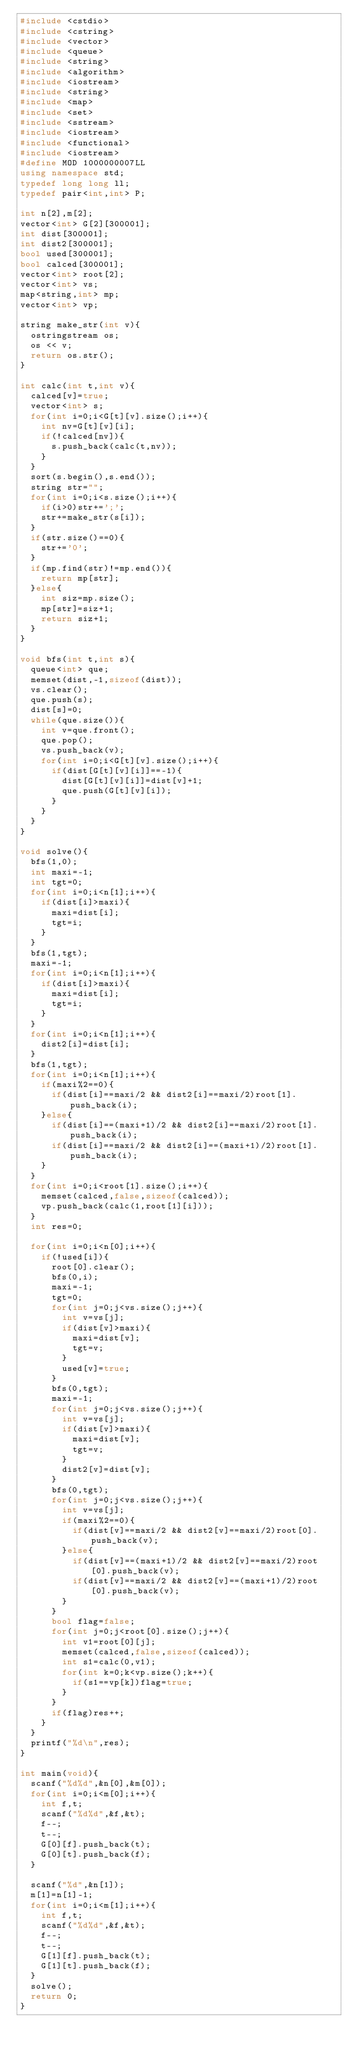<code> <loc_0><loc_0><loc_500><loc_500><_C++_>#include <cstdio>
#include <cstring>
#include <vector>
#include <queue>
#include <string>
#include <algorithm>
#include <iostream>
#include <string>
#include <map>
#include <set>
#include <sstream>
#include <iostream>
#include <functional>
#include <iostream>
#define MOD 1000000007LL
using namespace std;
typedef long long ll;
typedef pair<int,int> P;

int n[2],m[2];
vector<int> G[2][300001];
int dist[300001];
int dist2[300001];
bool used[300001];
bool calced[300001];
vector<int> root[2];
vector<int> vs;
map<string,int> mp;
vector<int> vp;

string make_str(int v){
	ostringstream os;
	os << v;
	return os.str();
}

int calc(int t,int v){
	calced[v]=true;
	vector<int> s;
	for(int i=0;i<G[t][v].size();i++){
		int nv=G[t][v][i];
		if(!calced[nv]){
			s.push_back(calc(t,nv));
		}
	}
	sort(s.begin(),s.end());
	string str="";
	for(int i=0;i<s.size();i++){
		if(i>0)str+=';';
		str+=make_str(s[i]);
	}
	if(str.size()==0){
		str+='0';
	}
	if(mp.find(str)!=mp.end()){
		return mp[str];
	}else{
		int siz=mp.size();
		mp[str]=siz+1;
		return siz+1;
	}
}

void bfs(int t,int s){
	queue<int> que;
	memset(dist,-1,sizeof(dist));
	vs.clear();
	que.push(s);
	dist[s]=0;
	while(que.size()){
		int v=que.front();
		que.pop();
		vs.push_back(v);
		for(int i=0;i<G[t][v].size();i++){
			if(dist[G[t][v][i]]==-1){
				dist[G[t][v][i]]=dist[v]+1;
				que.push(G[t][v][i]);
			}
		}
	}
}

void solve(){
	bfs(1,0);
	int maxi=-1;
	int tgt=0;
	for(int i=0;i<n[1];i++){
		if(dist[i]>maxi){
			maxi=dist[i];
			tgt=i;
		}
	}
	bfs(1,tgt);
	maxi=-1;
	for(int i=0;i<n[1];i++){
		if(dist[i]>maxi){
			maxi=dist[i];
			tgt=i;
		}
	}
	for(int i=0;i<n[1];i++){
		dist2[i]=dist[i];
	}
	bfs(1,tgt);
	for(int i=0;i<n[1];i++){
		if(maxi%2==0){
			if(dist[i]==maxi/2 && dist2[i]==maxi/2)root[1].push_back(i);
		}else{
			if(dist[i]==(maxi+1)/2 && dist2[i]==maxi/2)root[1].push_back(i);
			if(dist[i]==maxi/2 && dist2[i]==(maxi+1)/2)root[1].push_back(i);
		}
	}
	for(int i=0;i<root[1].size();i++){
		memset(calced,false,sizeof(calced));
		vp.push_back(calc(1,root[1][i]));
	}
	int res=0;

	for(int i=0;i<n[0];i++){
		if(!used[i]){
			root[0].clear();
			bfs(0,i);
			maxi=-1;
			tgt=0;
			for(int j=0;j<vs.size();j++){
				int v=vs[j];
				if(dist[v]>maxi){
					maxi=dist[v];
					tgt=v;
				}
				used[v]=true;
			}
			bfs(0,tgt);
			maxi=-1;
			for(int j=0;j<vs.size();j++){
				int v=vs[j];
				if(dist[v]>maxi){
					maxi=dist[v];
					tgt=v;
				}
				dist2[v]=dist[v];
			}
			bfs(0,tgt);
			for(int j=0;j<vs.size();j++){
				int v=vs[j];
				if(maxi%2==0){
					if(dist[v]==maxi/2 && dist2[v]==maxi/2)root[0].push_back(v);
				}else{
					if(dist[v]==(maxi+1)/2 && dist2[v]==maxi/2)root[0].push_back(v);
					if(dist[v]==maxi/2 && dist2[v]==(maxi+1)/2)root[0].push_back(v);
				}
			}
			bool flag=false;
			for(int j=0;j<root[0].size();j++){
				int v1=root[0][j];
				memset(calced,false,sizeof(calced));
				int s1=calc(0,v1);
				for(int k=0;k<vp.size();k++){
					if(s1==vp[k])flag=true;
				}
			}
			if(flag)res++;
		}
	}
	printf("%d\n",res);
}

int main(void){
	scanf("%d%d",&n[0],&m[0]);
	for(int i=0;i<m[0];i++){
		int f,t;
		scanf("%d%d",&f,&t);
		f--;
		t--;
		G[0][f].push_back(t);
		G[0][t].push_back(f);
	}

	scanf("%d",&n[1]);
	m[1]=n[1]-1;
	for(int i=0;i<m[1];i++){
		int f,t;
		scanf("%d%d",&f,&t);
		f--;
		t--;
		G[1][f].push_back(t);
		G[1][t].push_back(f);
	}
	solve();
	return 0;
}</code> 